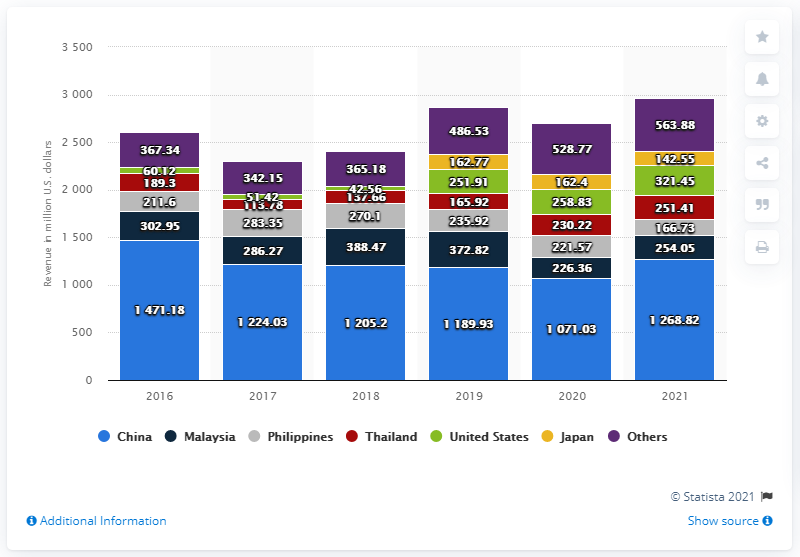Draw attention to some important aspects in this diagram. Marvell Technology's revenue in China in 2021 was 1,268.82 million. 